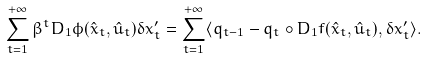Convert formula to latex. <formula><loc_0><loc_0><loc_500><loc_500>\sum _ { t = 1 } ^ { + \infty } \beta ^ { t } D _ { 1 } \phi ( \hat { x } _ { t } , \hat { u } _ { t } ) \delta x ^ { \prime } _ { t } = \sum _ { t = 1 } ^ { + \infty } \langle q _ { t - 1 } - q _ { t } \circ D _ { 1 } f ( \hat { x } _ { t } , \hat { u } _ { t } ) , \delta x ^ { \prime } _ { t } \rangle .</formula> 